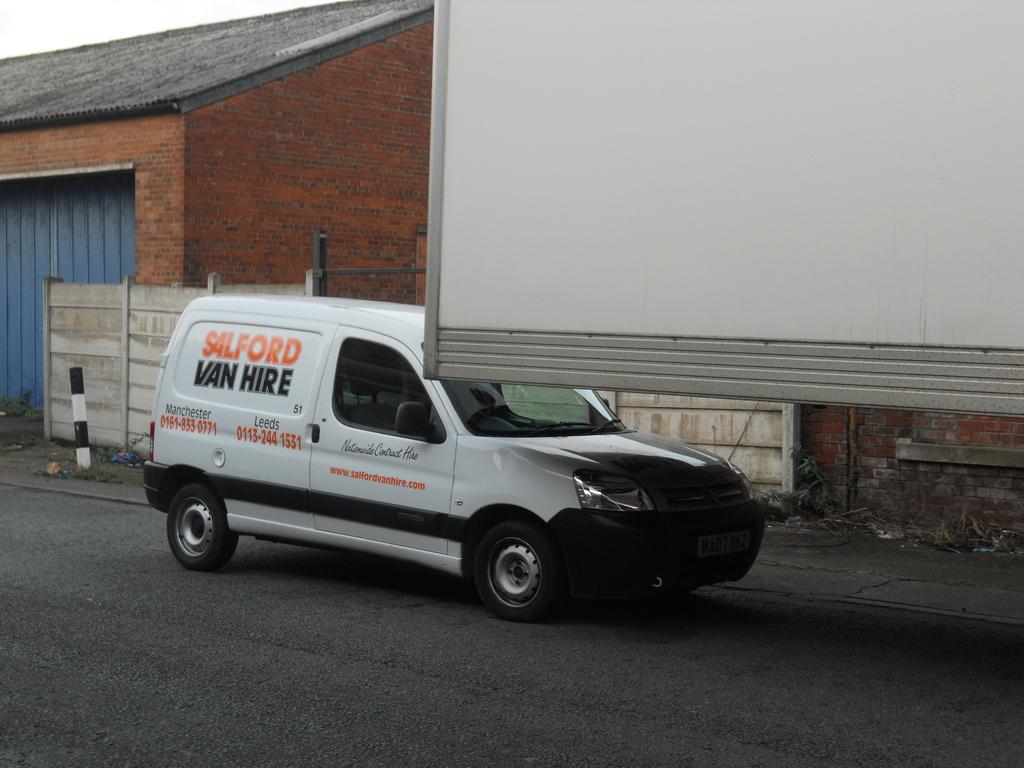<image>
Offer a succinct explanation of the picture presented. White van which says "Salford Van Hire" on it. 